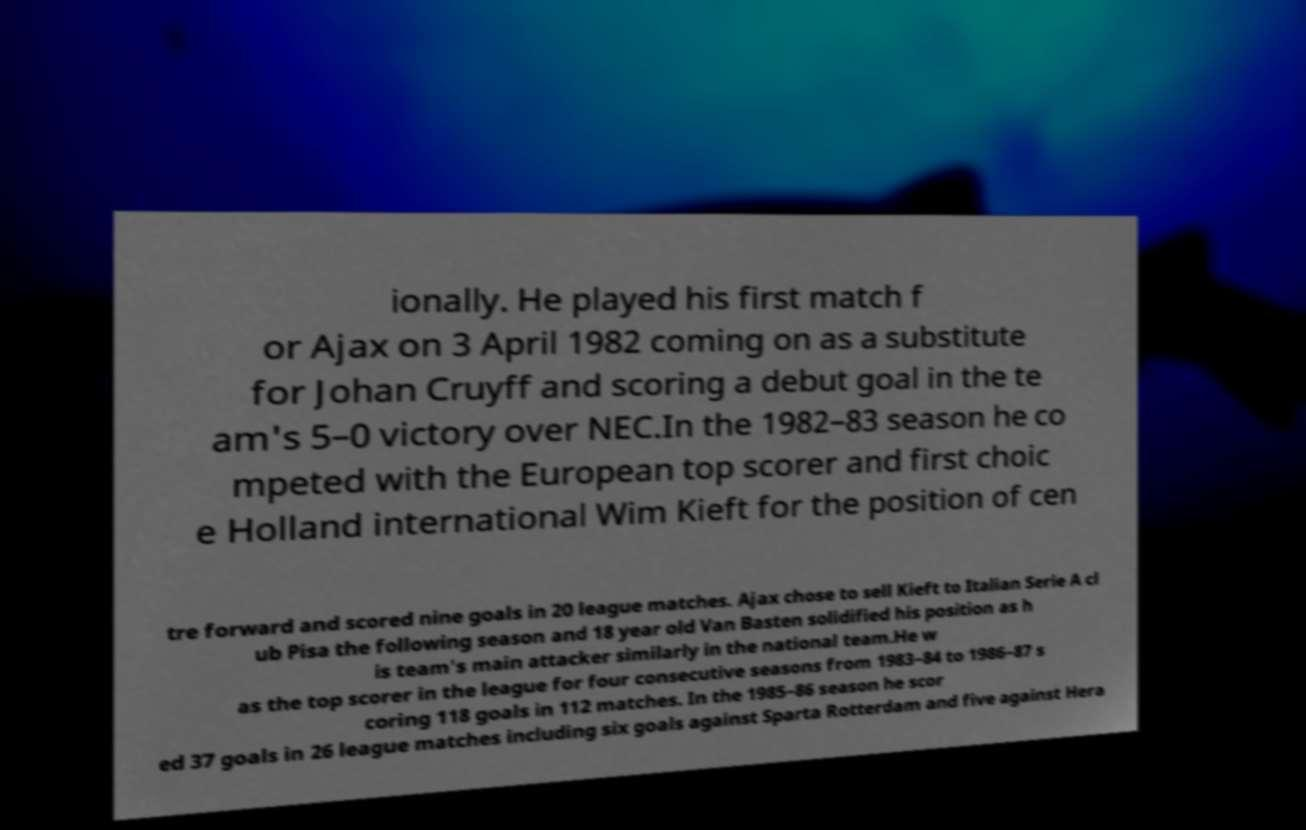Could you assist in decoding the text presented in this image and type it out clearly? ionally. He played his first match f or Ajax on 3 April 1982 coming on as a substitute for Johan Cruyff and scoring a debut goal in the te am's 5–0 victory over NEC.In the 1982–83 season he co mpeted with the European top scorer and first choic e Holland international Wim Kieft for the position of cen tre forward and scored nine goals in 20 league matches. Ajax chose to sell Kieft to Italian Serie A cl ub Pisa the following season and 18 year old Van Basten solidified his position as h is team's main attacker similarly in the national team.He w as the top scorer in the league for four consecutive seasons from 1983–84 to 1986–87 s coring 118 goals in 112 matches. In the 1985–86 season he scor ed 37 goals in 26 league matches including six goals against Sparta Rotterdam and five against Hera 